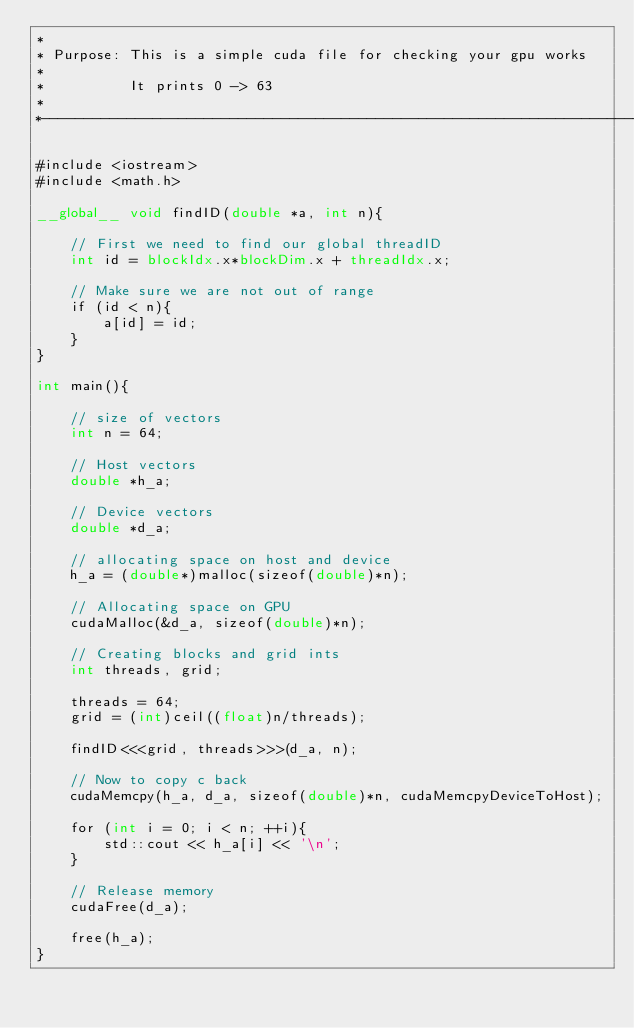Convert code to text. <code><loc_0><loc_0><loc_500><loc_500><_Cuda_>*
* Purpose: This is a simple cuda file for checking your gpu works
*
*          It prints 0 -> 63
*
*-----------------------------------------------------------------------------*/

#include <iostream>
#include <math.h>

__global__ void findID(double *a, int n){

    // First we need to find our global threadID
    int id = blockIdx.x*blockDim.x + threadIdx.x;

    // Make sure we are not out of range
    if (id < n){
        a[id] = id;
    }
}

int main(){

    // size of vectors
    int n = 64;

    // Host vectors
    double *h_a;

    // Device vectors
    double *d_a;

    // allocating space on host and device
    h_a = (double*)malloc(sizeof(double)*n);

    // Allocating space on GPU
    cudaMalloc(&d_a, sizeof(double)*n);

    // Creating blocks and grid ints
    int threads, grid;

    threads = 64;
    grid = (int)ceil((float)n/threads);

    findID<<<grid, threads>>>(d_a, n);

    // Now to copy c back
    cudaMemcpy(h_a, d_a, sizeof(double)*n, cudaMemcpyDeviceToHost);

    for (int i = 0; i < n; ++i){
        std::cout << h_a[i] << '\n';
    }

    // Release memory
    cudaFree(d_a);

    free(h_a);
}
</code> 